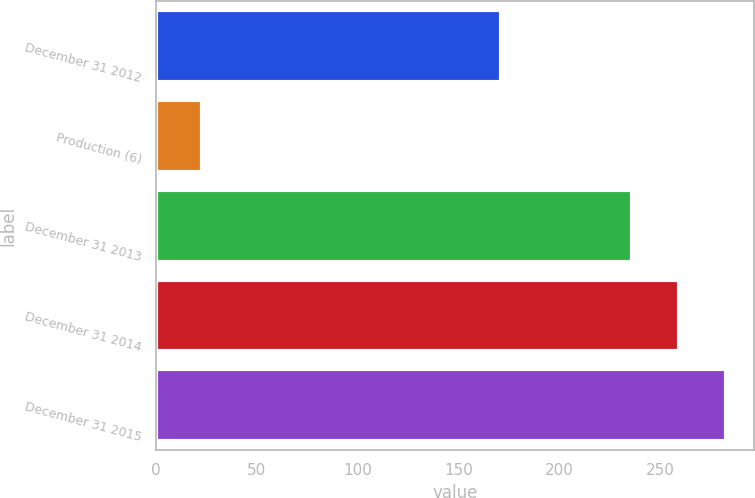Convert chart. <chart><loc_0><loc_0><loc_500><loc_500><bar_chart><fcel>December 31 2012<fcel>Production (6)<fcel>December 31 2013<fcel>December 31 2014<fcel>December 31 2015<nl><fcel>171<fcel>23<fcel>236<fcel>259.3<fcel>282.6<nl></chart> 